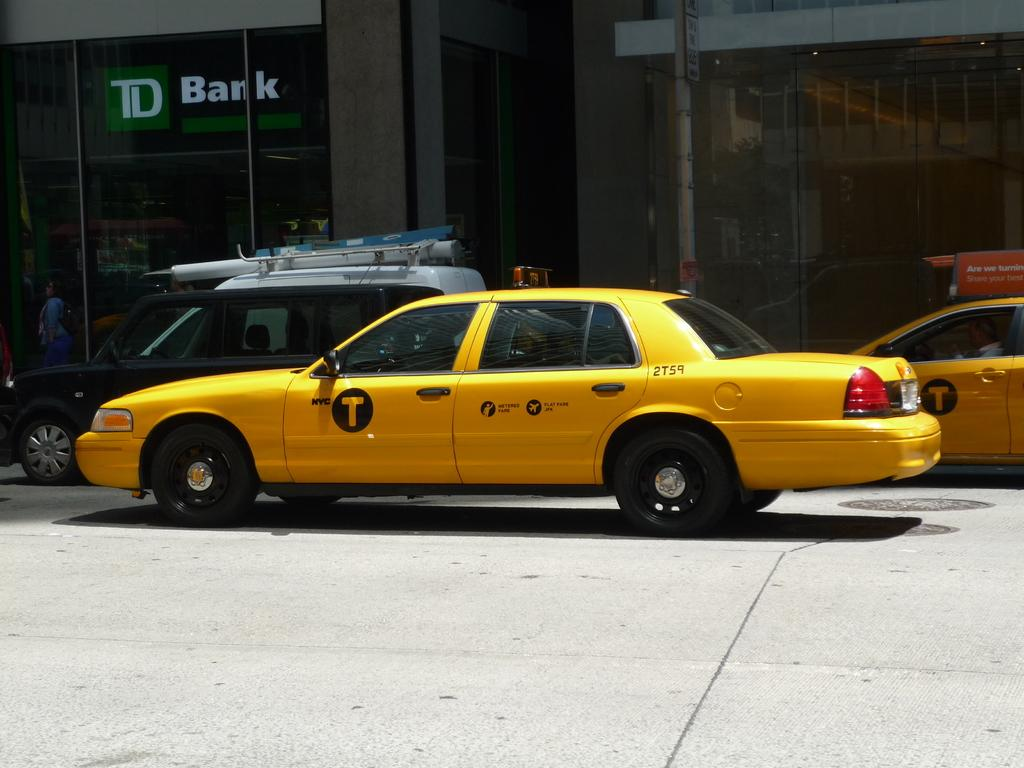<image>
Render a clear and concise summary of the photo. A yellow cab advertisng flat fares to JFK airport in front of a TD Bank location 